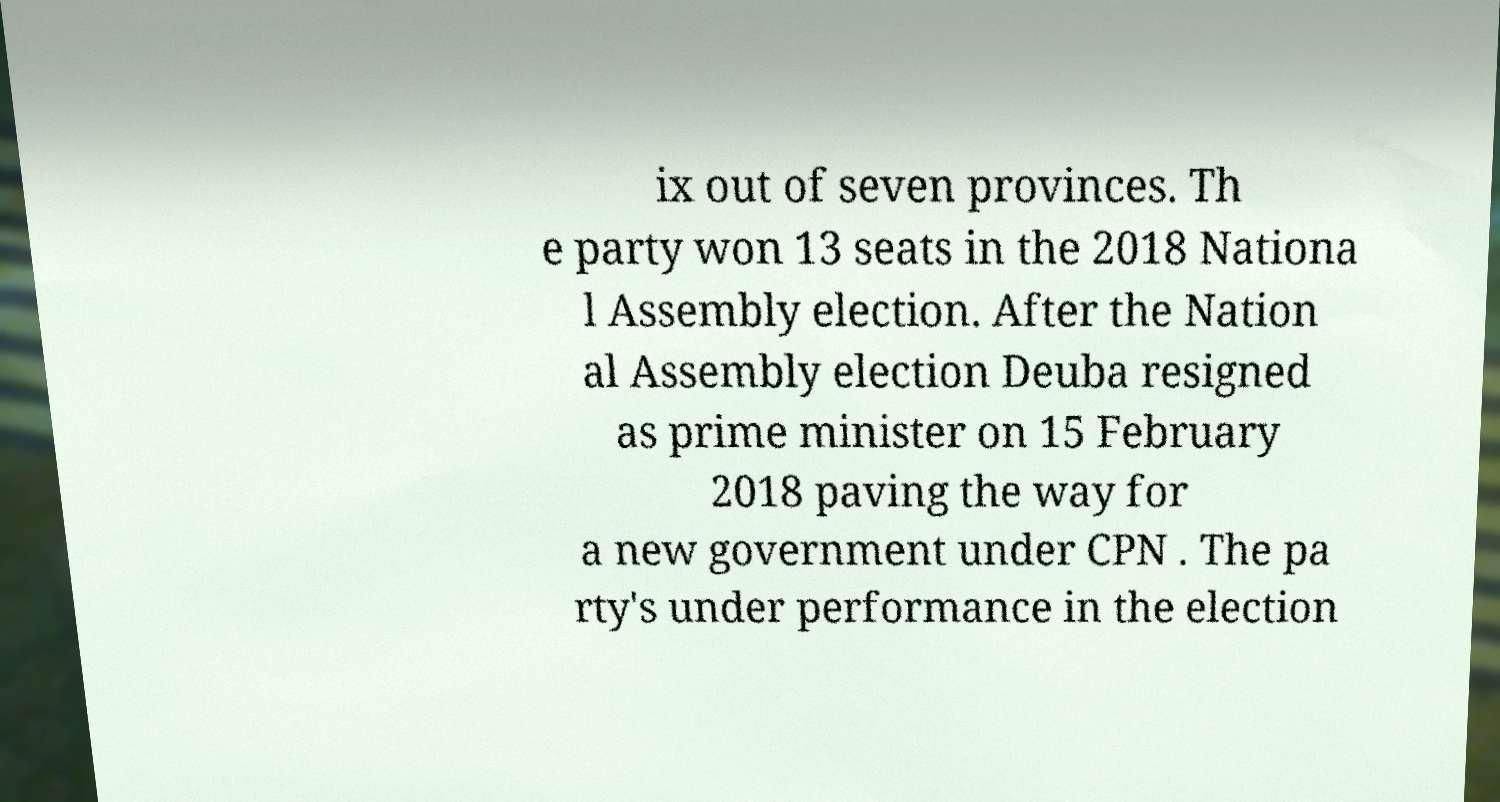Could you extract and type out the text from this image? ix out of seven provinces. Th e party won 13 seats in the 2018 Nationa l Assembly election. After the Nation al Assembly election Deuba resigned as prime minister on 15 February 2018 paving the way for a new government under CPN . The pa rty's under performance in the election 